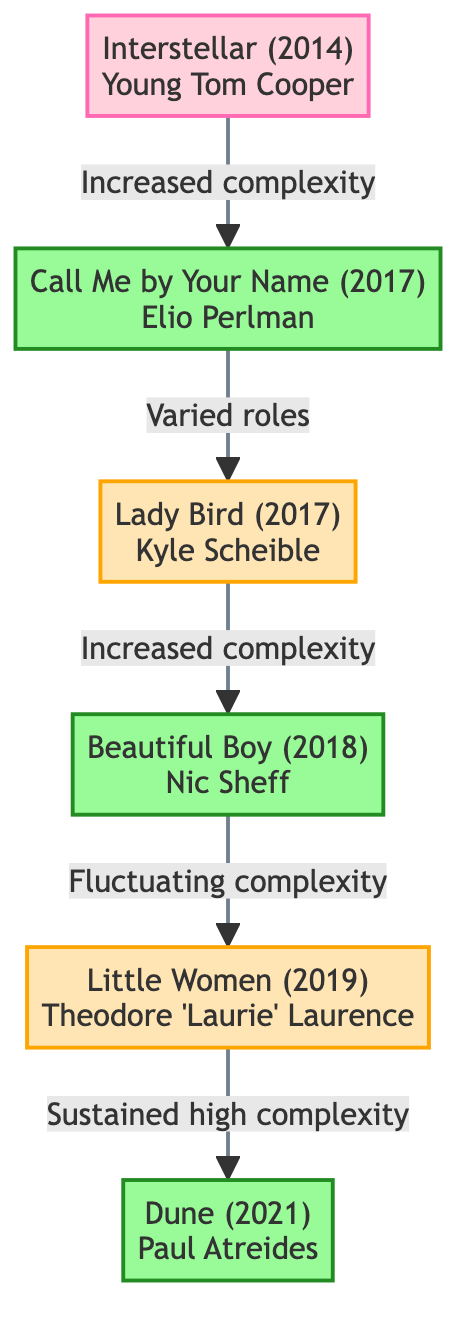What is the character in "Interstellar"? According to the diagram, "Interstellar (2014)" features the character "Young Tom Cooper."
Answer: Young Tom Cooper Which film shows the highest character complexity? The diagram indicates "Call Me by Your Name (2017)" and "Beautiful Boy (2018)" are labeled as having high complexity. However, the first film listed with this designation is "Call Me by Your Name."
Answer: Call Me by Your Name How many films are represented in the diagram? The diagram lists a total of five films: "Interstellar," "Call Me by Your Name," "Lady Bird," "Beautiful Boy," "Little Women," and "Dune." This totals to six movies.
Answer: 6 What type of complexity does "Little Women" have? The diagram categorizes "Little Women (2019)" as medium complexity.
Answer: Medium Complexity What is the relationship between "Lady Bird" and "Beautiful Boy"? The diagram indicates that "Lady Bird" leads to "Beautiful Boy," marked by the phrase "Increased complexity."
Answer: Increased complexity What character does Timothée play in "Dune"? According to the diagram, in "Dune (2021)," Timothée Chalamet plays the character "Paul Atreides."
Answer: Paul Atreides Which film comes after "Beautiful Boy" in the diagram? Following the flow in the diagram, "Little Women" comes next after "Beautiful Boy."
Answer: Little Women Which film marked a transition to higher complexity after "Interstellar"? As per the diagram, the film "Call Me by Your Name" marks the transition to higher complexity after "Interstellar."
Answer: Call Me by Your Name What is the complexity trend shown from "Lady Bird" to "Little Women"? The diagram shows a fluctuation in complexity from "Lady Bird" to "Beautiful Boy," and then a sustained high complexity in "Little Women."
Answer: Fluctuating complexity 